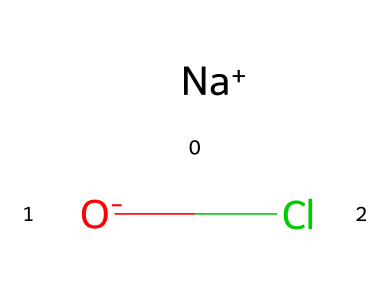What is the main component of the chemical represented here? The chemical structure includes sodium (Na) and chlorine (Cl) as well as an oxygen atom. The presence of chlorine indicates that the main component is a chloride compound.
Answer: chloride How many total atoms are in the structure? The structure consists of one sodium atom, one oxygen atom, and one chlorine atom, totaling three atoms in the chemical formula.
Answer: 3 What type of bond is present between the chlorine and sodium? In this chemical structure, there is an ionic bond between the sodium (positively charged) and the chloride ion (negatively charged), which is common in salts.
Answer: ionic What role does chlorine play in household cleaning products? Chlorine is commonly used as a disinfectant in household cleaning products due to its ability to kill bacteria and viruses, making it effective for sanitization.
Answer: disinfectant How does the presence of oxygen affect the reactivity of chlorine in this compound? The oxygen in this compound could influence the reactivity by enabling chlorine to participate in redox reactions or changing its oxidation state, which can enhance its efficacy as a disinfectant.
Answer: enhances reactivity Which group of elements does chlorine belong to? Chlorine is classified as a halogen, which is a group of elements known for their high reactivity and tendency to form salts with metals.
Answer: halogens 